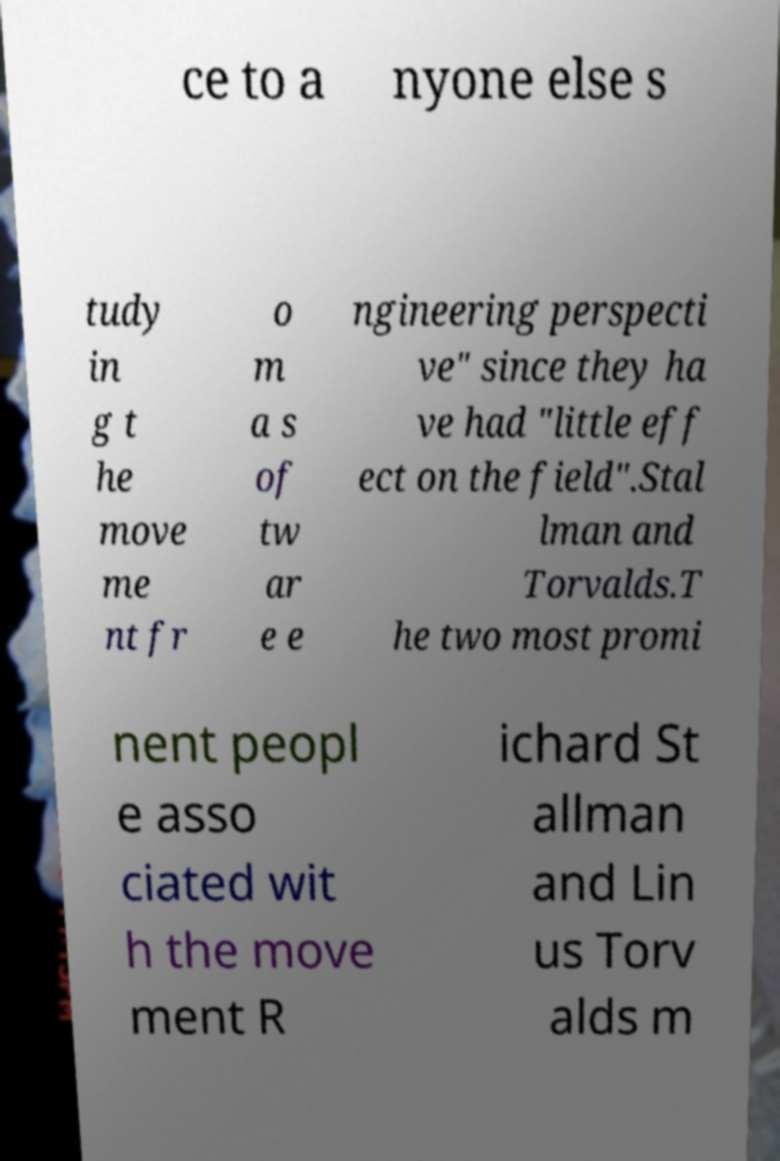Please identify and transcribe the text found in this image. ce to a nyone else s tudy in g t he move me nt fr o m a s of tw ar e e ngineering perspecti ve" since they ha ve had "little eff ect on the field".Stal lman and Torvalds.T he two most promi nent peopl e asso ciated wit h the move ment R ichard St allman and Lin us Torv alds m 